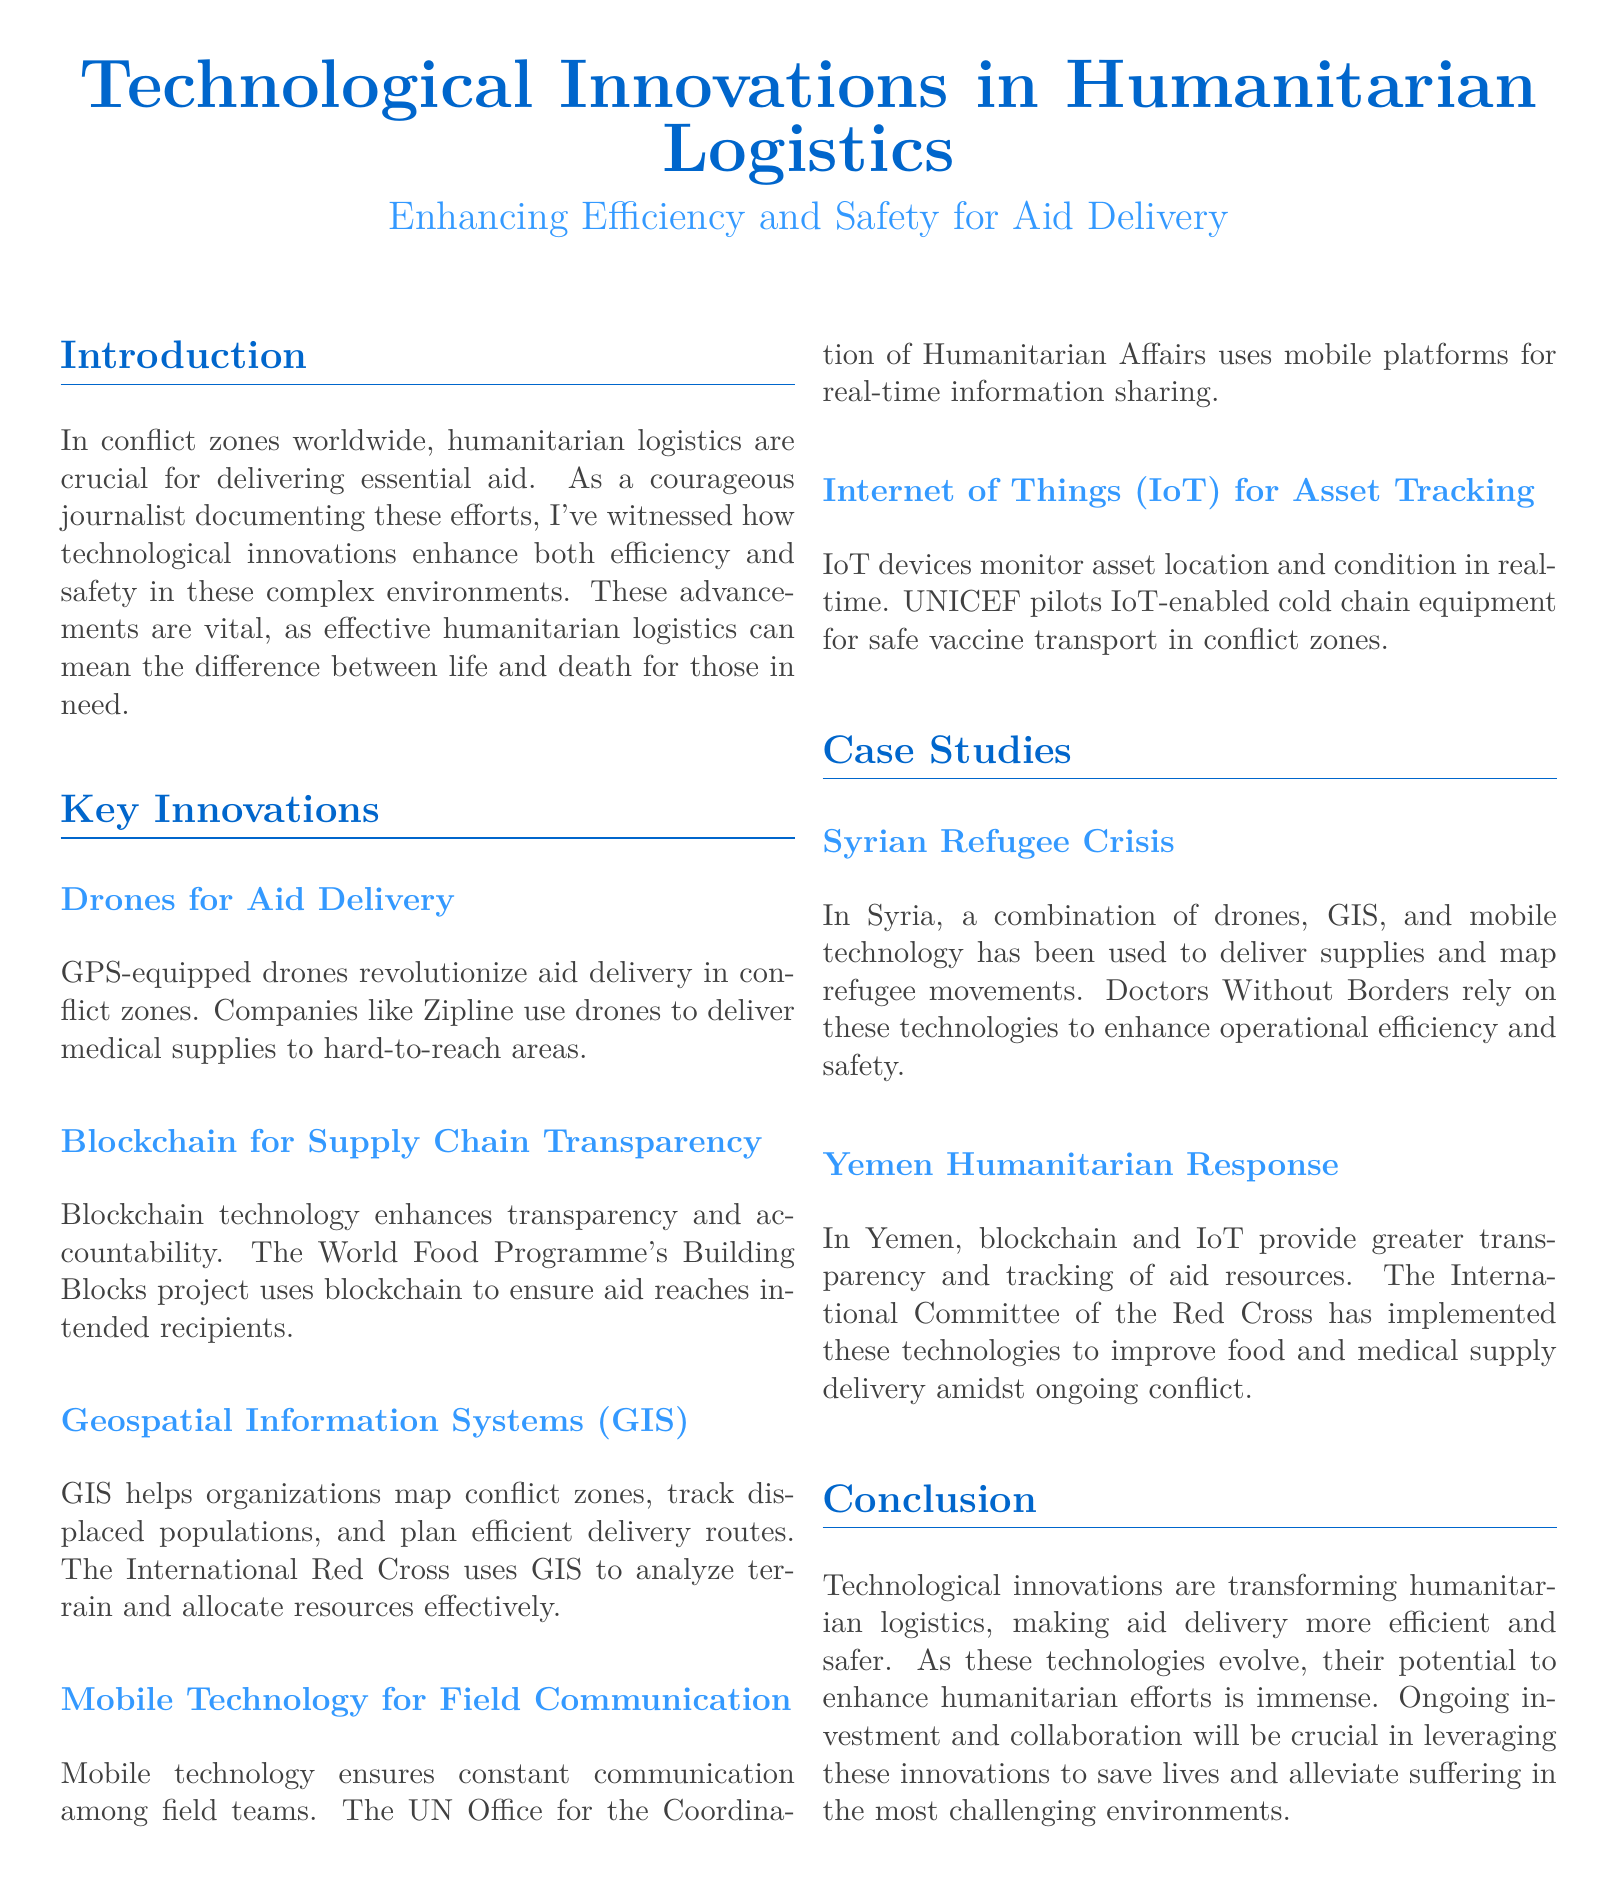What is the main focus of the whitepaper? The main focus of the whitepaper is to discuss technological innovations in humanitarian logistics that enhance efficiency and safety for aid delivery in conflict zones.
Answer: Technological innovations in humanitarian logistics What organization uses drones to deliver medical supplies? The document mentions that Zipline is a company that uses drones to deliver medical supplies to hard-to-reach areas.
Answer: Zipline What technology is used for supply chain transparency in humanitarian efforts? Blockchain technology is highlighted as a means to enhance transparency and accountability in humanitarian logistics.
Answer: Blockchain Which organization employs GIS to analyze terrain? The International Red Cross is the organization mentioned that uses GIS to analyze terrain and allocate resources effectively.
Answer: International Red Cross What is the role of mobile technology in humanitarian logistics? Mobile technology ensures constant communication among field teams for real-time information sharing.
Answer: Constant communication How is data used in the Syrian refugee crisis? In Syria, a combination of drones, GIS, and mobile technology has been used to deliver supplies and map refugee movements.
Answer: Deliver supplies and map refugee movements What are the benefits of IoT in humanitarian logistics? IoT devices are used to monitor asset location and condition in real-time, improving tracking of resources.
Answer: Monitor asset location and condition What project does the World Food Programme use for blockchain implementation? The World Food Programme's Building Blocks project uses blockchain to ensure aid reaches intended recipients.
Answer: Building Blocks What is a key takeaway about the future of humanitarian logistics? Ongoing investment and collaboration are crucial to leveraging technological innovations for saving lives and alleviating suffering.
Answer: Ongoing investment and collaboration 